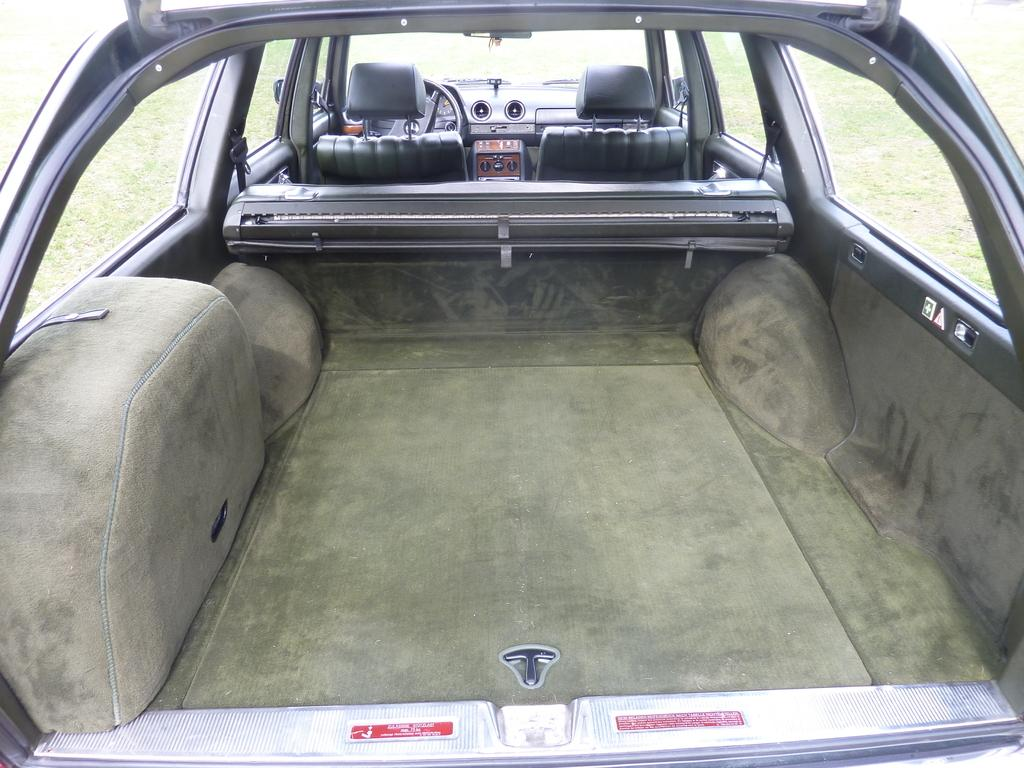What type of space is depicted in the image? The image shows an inside view of a vehicle. What can be found inside the vehicle? There are seats, a steering wheel, and speedometers in the vehicle. What feature allows for visibility and separation between the inside and outside of the vehicle? There are glass doors in the vehicle. What can be seen through the glass doors? Grass is visible through the glass doors. How many planes are parked on the grass outside the vehicle in the image? There are no planes visible in the image; it only shows an inside view of a vehicle with grass visible through the glass doors. What type of flowers can be seen growing near the vehicle in the image? There are no flowers visible in the image; it only shows an inside view of a vehicle with grass visible through the glass doors. 